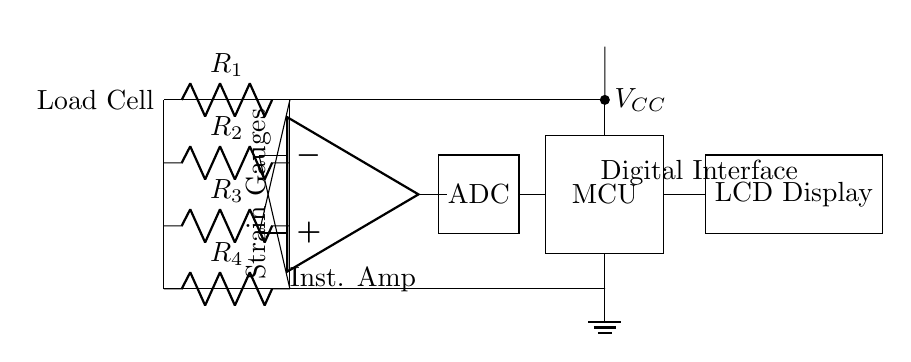What type of circuit is used in this design? The circuit is a hybrid circuit, combining analog components like load cells and instrumentation amplifiers with digital components such as an ADC and microcontroller.
Answer: Hybrid circuit What is the function of the load cell? The load cell is used to measure weight by converting mechanical force into an electrical signal through strain gauges.
Answer: Measure weight How many strain gauges are utilized in the load cell? There are four strain gauges (R1, R2, R3, R4) used in this configuration.
Answer: Four Which component converts the analog signal to digital? The ADC (Analog to Digital Converter) is responsible for converting the analog signal from the instrumentation amplifier into a digital format for the microcontroller.
Answer: ADC Where is the power supply connected in the circuit? The power supply is connected to the microcontroller and is also linked to the load cell, providing necessary voltage for operation.
Answer: Microcontroller What device provides the final output to the user? The final output is displayed on the LCD, which presents the measured weight to the user in a readable format.
Answer: LCD Display How does the instrumentation amplifier function in this circuit? The instrumentation amplifier amplifies the small signal from the load cell, allowing it to be processed further by the ADC and microcontroller.
Answer: Amplifies signal 